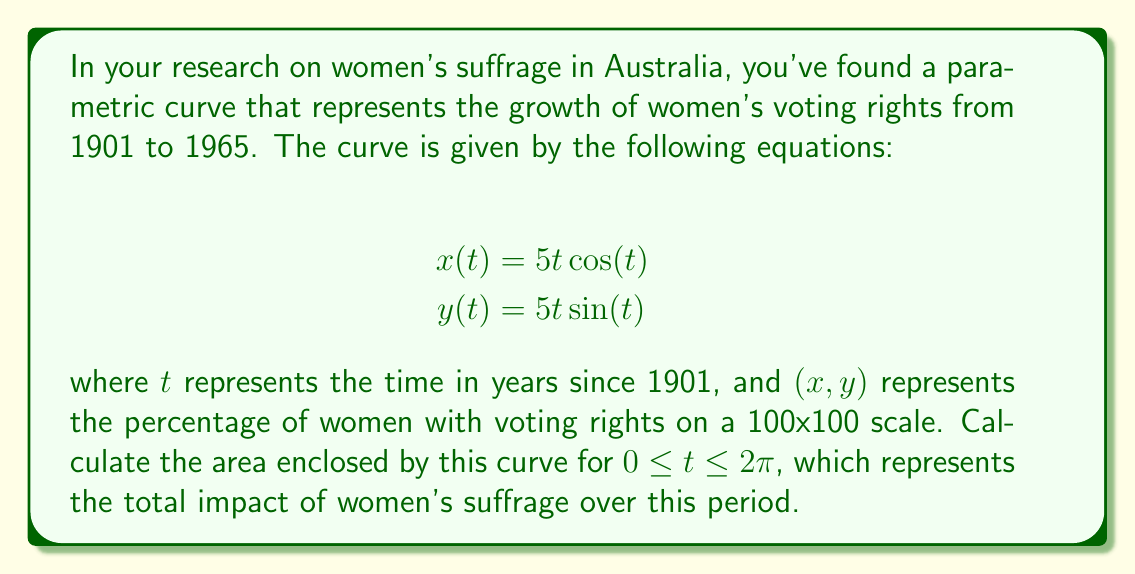Solve this math problem. To calculate the area enclosed by a parametric curve, we can use the formula:

$$\text{Area} = \frac{1}{2}\int_a^b [x(t)\frac{dy}{dt} - y(t)\frac{dx}{dt}] dt$$

where $a$ and $b$ are the start and end values of the parameter $t$.

Step 1: Calculate $\frac{dx}{dt}$ and $\frac{dy}{dt}$
$$\frac{dx}{dt} = 5\cos(t) - 5t\sin(t)$$
$$\frac{dy}{dt} = 5\sin(t) + 5t\cos(t)$$

Step 2: Substitute these into the area formula
$$\text{Area} = \frac{1}{2}\int_0^{2\pi} [(5t\cos(t))(5\sin(t) + 5t\cos(t)) - (5t\sin(t))(5\cos(t) - 5t\sin(t))] dt$$

Step 3: Simplify the integrand
$$\text{Area} = \frac{1}{2}\int_0^{2\pi} [25t\cos(t)\sin(t) + 25t^2\cos^2(t) - 25t\cos(t)\sin(t) + 25t^2\sin^2(t)] dt$$
$$\text{Area} = \frac{1}{2}\int_0^{2\pi} 25t^2(\cos^2(t) + \sin^2(t)) dt$$
$$\text{Area} = \frac{1}{2}\int_0^{2\pi} 25t^2 dt$$ (since $\cos^2(t) + \sin^2(t) = 1$)

Step 4: Integrate
$$\text{Area} = \frac{1}{2} \cdot 25 \cdot \frac{t^3}{3} \bigg|_0^{2\pi}$$
$$\text{Area} = \frac{25}{6}[(2\pi)^3 - 0^3]$$
$$\text{Area} = \frac{25}{6}(8\pi^3)$$
$$\text{Area} = \frac{100\pi^3}{3}$$

Therefore, the area enclosed by the parametric curve is $\frac{100\pi^3}{3}$ square units.
Answer: $\frac{100\pi^3}{3}$ square units 